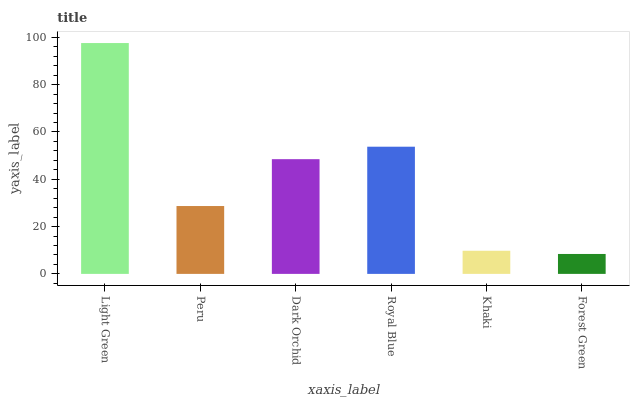Is Forest Green the minimum?
Answer yes or no. Yes. Is Light Green the maximum?
Answer yes or no. Yes. Is Peru the minimum?
Answer yes or no. No. Is Peru the maximum?
Answer yes or no. No. Is Light Green greater than Peru?
Answer yes or no. Yes. Is Peru less than Light Green?
Answer yes or no. Yes. Is Peru greater than Light Green?
Answer yes or no. No. Is Light Green less than Peru?
Answer yes or no. No. Is Dark Orchid the high median?
Answer yes or no. Yes. Is Peru the low median?
Answer yes or no. Yes. Is Light Green the high median?
Answer yes or no. No. Is Royal Blue the low median?
Answer yes or no. No. 